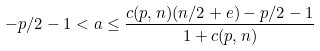Convert formula to latex. <formula><loc_0><loc_0><loc_500><loc_500>- p / 2 - 1 < a \leq \frac { c ( p , n ) ( n / 2 + e ) - p / 2 - 1 } { 1 + c ( p , n ) }</formula> 